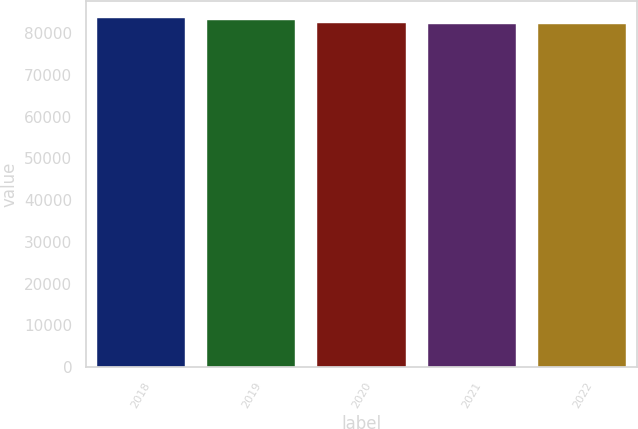Convert chart to OTSL. <chart><loc_0><loc_0><loc_500><loc_500><bar_chart><fcel>2018<fcel>2019<fcel>2020<fcel>2021<fcel>2022<nl><fcel>83564<fcel>83137<fcel>82348<fcel>82044<fcel>82196<nl></chart> 